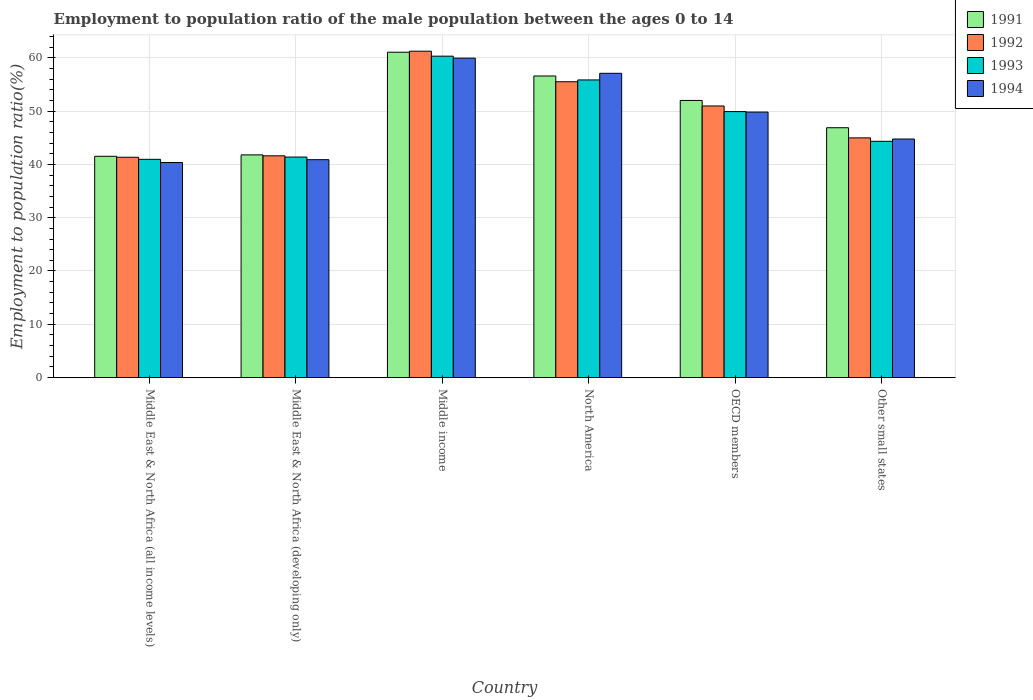How many different coloured bars are there?
Keep it short and to the point. 4. How many bars are there on the 2nd tick from the left?
Offer a very short reply. 4. How many bars are there on the 1st tick from the right?
Keep it short and to the point. 4. In how many cases, is the number of bars for a given country not equal to the number of legend labels?
Your response must be concise. 0. What is the employment to population ratio in 1993 in Middle East & North Africa (developing only)?
Offer a terse response. 41.37. Across all countries, what is the maximum employment to population ratio in 1994?
Keep it short and to the point. 59.91. Across all countries, what is the minimum employment to population ratio in 1992?
Offer a very short reply. 41.33. In which country was the employment to population ratio in 1993 minimum?
Provide a succinct answer. Middle East & North Africa (all income levels). What is the total employment to population ratio in 1992 in the graph?
Ensure brevity in your answer.  295.53. What is the difference between the employment to population ratio in 1992 in Middle East & North Africa (all income levels) and that in Other small states?
Make the answer very short. -3.64. What is the difference between the employment to population ratio in 1994 in Middle income and the employment to population ratio in 1992 in OECD members?
Your response must be concise. 8.96. What is the average employment to population ratio in 1991 per country?
Provide a short and direct response. 49.95. What is the difference between the employment to population ratio of/in 1994 and employment to population ratio of/in 1991 in OECD members?
Make the answer very short. -2.18. In how many countries, is the employment to population ratio in 1993 greater than 34 %?
Give a very brief answer. 6. What is the ratio of the employment to population ratio in 1992 in Middle East & North Africa (all income levels) to that in Middle income?
Your answer should be very brief. 0.68. Is the employment to population ratio in 1994 in Middle East & North Africa (all income levels) less than that in North America?
Your answer should be very brief. Yes. What is the difference between the highest and the second highest employment to population ratio in 1993?
Offer a terse response. -10.39. What is the difference between the highest and the lowest employment to population ratio in 1992?
Give a very brief answer. 19.89. What does the 2nd bar from the left in OECD members represents?
Give a very brief answer. 1992. Is it the case that in every country, the sum of the employment to population ratio in 1991 and employment to population ratio in 1994 is greater than the employment to population ratio in 1992?
Your answer should be very brief. Yes. How many bars are there?
Offer a terse response. 24. How many countries are there in the graph?
Keep it short and to the point. 6. What is the difference between two consecutive major ticks on the Y-axis?
Your response must be concise. 10. Does the graph contain any zero values?
Offer a very short reply. No. Does the graph contain grids?
Provide a succinct answer. Yes. What is the title of the graph?
Your answer should be very brief. Employment to population ratio of the male population between the ages 0 to 14. Does "1983" appear as one of the legend labels in the graph?
Keep it short and to the point. No. What is the label or title of the Y-axis?
Offer a very short reply. Employment to population ratio(%). What is the Employment to population ratio(%) of 1991 in Middle East & North Africa (all income levels)?
Your answer should be compact. 41.51. What is the Employment to population ratio(%) of 1992 in Middle East & North Africa (all income levels)?
Give a very brief answer. 41.33. What is the Employment to population ratio(%) in 1993 in Middle East & North Africa (all income levels)?
Ensure brevity in your answer.  40.94. What is the Employment to population ratio(%) in 1994 in Middle East & North Africa (all income levels)?
Provide a short and direct response. 40.34. What is the Employment to population ratio(%) of 1991 in Middle East & North Africa (developing only)?
Keep it short and to the point. 41.77. What is the Employment to population ratio(%) of 1992 in Middle East & North Africa (developing only)?
Make the answer very short. 41.6. What is the Employment to population ratio(%) in 1993 in Middle East & North Africa (developing only)?
Ensure brevity in your answer.  41.37. What is the Employment to population ratio(%) of 1994 in Middle East & North Africa (developing only)?
Offer a very short reply. 40.87. What is the Employment to population ratio(%) in 1991 in Middle income?
Offer a very short reply. 61.02. What is the Employment to population ratio(%) in 1992 in Middle income?
Your response must be concise. 61.21. What is the Employment to population ratio(%) of 1993 in Middle income?
Provide a succinct answer. 60.28. What is the Employment to population ratio(%) of 1994 in Middle income?
Offer a terse response. 59.91. What is the Employment to population ratio(%) of 1991 in North America?
Your response must be concise. 56.57. What is the Employment to population ratio(%) in 1992 in North America?
Keep it short and to the point. 55.48. What is the Employment to population ratio(%) of 1993 in North America?
Your answer should be compact. 55.83. What is the Employment to population ratio(%) in 1994 in North America?
Give a very brief answer. 57.07. What is the Employment to population ratio(%) of 1991 in OECD members?
Your answer should be compact. 51.98. What is the Employment to population ratio(%) in 1992 in OECD members?
Your answer should be very brief. 50.95. What is the Employment to population ratio(%) of 1993 in OECD members?
Offer a terse response. 49.89. What is the Employment to population ratio(%) of 1994 in OECD members?
Offer a terse response. 49.8. What is the Employment to population ratio(%) in 1991 in Other small states?
Offer a terse response. 46.86. What is the Employment to population ratio(%) in 1992 in Other small states?
Offer a very short reply. 44.96. What is the Employment to population ratio(%) of 1993 in Other small states?
Give a very brief answer. 44.32. What is the Employment to population ratio(%) of 1994 in Other small states?
Give a very brief answer. 44.75. Across all countries, what is the maximum Employment to population ratio(%) in 1991?
Your answer should be very brief. 61.02. Across all countries, what is the maximum Employment to population ratio(%) in 1992?
Your answer should be compact. 61.21. Across all countries, what is the maximum Employment to population ratio(%) in 1993?
Keep it short and to the point. 60.28. Across all countries, what is the maximum Employment to population ratio(%) of 1994?
Offer a very short reply. 59.91. Across all countries, what is the minimum Employment to population ratio(%) in 1991?
Offer a terse response. 41.51. Across all countries, what is the minimum Employment to population ratio(%) in 1992?
Your answer should be very brief. 41.33. Across all countries, what is the minimum Employment to population ratio(%) of 1993?
Your answer should be very brief. 40.94. Across all countries, what is the minimum Employment to population ratio(%) in 1994?
Keep it short and to the point. 40.34. What is the total Employment to population ratio(%) in 1991 in the graph?
Your response must be concise. 299.72. What is the total Employment to population ratio(%) of 1992 in the graph?
Your answer should be very brief. 295.53. What is the total Employment to population ratio(%) of 1993 in the graph?
Offer a terse response. 292.63. What is the total Employment to population ratio(%) in 1994 in the graph?
Ensure brevity in your answer.  292.74. What is the difference between the Employment to population ratio(%) of 1991 in Middle East & North Africa (all income levels) and that in Middle East & North Africa (developing only)?
Keep it short and to the point. -0.26. What is the difference between the Employment to population ratio(%) in 1992 in Middle East & North Africa (all income levels) and that in Middle East & North Africa (developing only)?
Ensure brevity in your answer.  -0.27. What is the difference between the Employment to population ratio(%) of 1993 in Middle East & North Africa (all income levels) and that in Middle East & North Africa (developing only)?
Provide a succinct answer. -0.43. What is the difference between the Employment to population ratio(%) of 1994 in Middle East & North Africa (all income levels) and that in Middle East & North Africa (developing only)?
Provide a succinct answer. -0.53. What is the difference between the Employment to population ratio(%) of 1991 in Middle East & North Africa (all income levels) and that in Middle income?
Offer a very short reply. -19.51. What is the difference between the Employment to population ratio(%) of 1992 in Middle East & North Africa (all income levels) and that in Middle income?
Ensure brevity in your answer.  -19.89. What is the difference between the Employment to population ratio(%) of 1993 in Middle East & North Africa (all income levels) and that in Middle income?
Ensure brevity in your answer.  -19.34. What is the difference between the Employment to population ratio(%) in 1994 in Middle East & North Africa (all income levels) and that in Middle income?
Your answer should be compact. -19.57. What is the difference between the Employment to population ratio(%) of 1991 in Middle East & North Africa (all income levels) and that in North America?
Provide a short and direct response. -15.06. What is the difference between the Employment to population ratio(%) of 1992 in Middle East & North Africa (all income levels) and that in North America?
Make the answer very short. -14.16. What is the difference between the Employment to population ratio(%) of 1993 in Middle East & North Africa (all income levels) and that in North America?
Offer a very short reply. -14.89. What is the difference between the Employment to population ratio(%) in 1994 in Middle East & North Africa (all income levels) and that in North America?
Give a very brief answer. -16.73. What is the difference between the Employment to population ratio(%) of 1991 in Middle East & North Africa (all income levels) and that in OECD members?
Your answer should be very brief. -10.47. What is the difference between the Employment to population ratio(%) of 1992 in Middle East & North Africa (all income levels) and that in OECD members?
Your response must be concise. -9.62. What is the difference between the Employment to population ratio(%) of 1993 in Middle East & North Africa (all income levels) and that in OECD members?
Give a very brief answer. -8.95. What is the difference between the Employment to population ratio(%) in 1994 in Middle East & North Africa (all income levels) and that in OECD members?
Keep it short and to the point. -9.46. What is the difference between the Employment to population ratio(%) of 1991 in Middle East & North Africa (all income levels) and that in Other small states?
Provide a short and direct response. -5.35. What is the difference between the Employment to population ratio(%) in 1992 in Middle East & North Africa (all income levels) and that in Other small states?
Give a very brief answer. -3.64. What is the difference between the Employment to population ratio(%) in 1993 in Middle East & North Africa (all income levels) and that in Other small states?
Make the answer very short. -3.38. What is the difference between the Employment to population ratio(%) of 1994 in Middle East & North Africa (all income levels) and that in Other small states?
Ensure brevity in your answer.  -4.41. What is the difference between the Employment to population ratio(%) of 1991 in Middle East & North Africa (developing only) and that in Middle income?
Provide a short and direct response. -19.25. What is the difference between the Employment to population ratio(%) in 1992 in Middle East & North Africa (developing only) and that in Middle income?
Ensure brevity in your answer.  -19.62. What is the difference between the Employment to population ratio(%) in 1993 in Middle East & North Africa (developing only) and that in Middle income?
Give a very brief answer. -18.92. What is the difference between the Employment to population ratio(%) in 1994 in Middle East & North Africa (developing only) and that in Middle income?
Your answer should be compact. -19.04. What is the difference between the Employment to population ratio(%) of 1991 in Middle East & North Africa (developing only) and that in North America?
Give a very brief answer. -14.8. What is the difference between the Employment to population ratio(%) in 1992 in Middle East & North Africa (developing only) and that in North America?
Your response must be concise. -13.89. What is the difference between the Employment to population ratio(%) in 1993 in Middle East & North Africa (developing only) and that in North America?
Your response must be concise. -14.46. What is the difference between the Employment to population ratio(%) of 1994 in Middle East & North Africa (developing only) and that in North America?
Offer a terse response. -16.19. What is the difference between the Employment to population ratio(%) in 1991 in Middle East & North Africa (developing only) and that in OECD members?
Offer a terse response. -10.21. What is the difference between the Employment to population ratio(%) of 1992 in Middle East & North Africa (developing only) and that in OECD members?
Give a very brief answer. -9.35. What is the difference between the Employment to population ratio(%) in 1993 in Middle East & North Africa (developing only) and that in OECD members?
Keep it short and to the point. -8.53. What is the difference between the Employment to population ratio(%) of 1994 in Middle East & North Africa (developing only) and that in OECD members?
Offer a very short reply. -8.92. What is the difference between the Employment to population ratio(%) in 1991 in Middle East & North Africa (developing only) and that in Other small states?
Your answer should be very brief. -5.09. What is the difference between the Employment to population ratio(%) in 1992 in Middle East & North Africa (developing only) and that in Other small states?
Your response must be concise. -3.37. What is the difference between the Employment to population ratio(%) in 1993 in Middle East & North Africa (developing only) and that in Other small states?
Keep it short and to the point. -2.95. What is the difference between the Employment to population ratio(%) of 1994 in Middle East & North Africa (developing only) and that in Other small states?
Provide a short and direct response. -3.87. What is the difference between the Employment to population ratio(%) of 1991 in Middle income and that in North America?
Your answer should be very brief. 4.45. What is the difference between the Employment to population ratio(%) in 1992 in Middle income and that in North America?
Ensure brevity in your answer.  5.73. What is the difference between the Employment to population ratio(%) of 1993 in Middle income and that in North America?
Keep it short and to the point. 4.46. What is the difference between the Employment to population ratio(%) in 1994 in Middle income and that in North America?
Keep it short and to the point. 2.84. What is the difference between the Employment to population ratio(%) of 1991 in Middle income and that in OECD members?
Your response must be concise. 9.04. What is the difference between the Employment to population ratio(%) in 1992 in Middle income and that in OECD members?
Offer a terse response. 10.27. What is the difference between the Employment to population ratio(%) in 1993 in Middle income and that in OECD members?
Offer a terse response. 10.39. What is the difference between the Employment to population ratio(%) of 1994 in Middle income and that in OECD members?
Offer a very short reply. 10.11. What is the difference between the Employment to population ratio(%) in 1991 in Middle income and that in Other small states?
Provide a succinct answer. 14.16. What is the difference between the Employment to population ratio(%) in 1992 in Middle income and that in Other small states?
Give a very brief answer. 16.25. What is the difference between the Employment to population ratio(%) in 1993 in Middle income and that in Other small states?
Your response must be concise. 15.96. What is the difference between the Employment to population ratio(%) of 1994 in Middle income and that in Other small states?
Keep it short and to the point. 15.16. What is the difference between the Employment to population ratio(%) of 1991 in North America and that in OECD members?
Your answer should be very brief. 4.59. What is the difference between the Employment to population ratio(%) of 1992 in North America and that in OECD members?
Ensure brevity in your answer.  4.54. What is the difference between the Employment to population ratio(%) in 1993 in North America and that in OECD members?
Make the answer very short. 5.93. What is the difference between the Employment to population ratio(%) in 1994 in North America and that in OECD members?
Provide a short and direct response. 7.27. What is the difference between the Employment to population ratio(%) of 1991 in North America and that in Other small states?
Make the answer very short. 9.7. What is the difference between the Employment to population ratio(%) in 1992 in North America and that in Other small states?
Provide a short and direct response. 10.52. What is the difference between the Employment to population ratio(%) of 1993 in North America and that in Other small states?
Make the answer very short. 11.51. What is the difference between the Employment to population ratio(%) of 1994 in North America and that in Other small states?
Keep it short and to the point. 12.32. What is the difference between the Employment to population ratio(%) of 1991 in OECD members and that in Other small states?
Provide a succinct answer. 5.12. What is the difference between the Employment to population ratio(%) of 1992 in OECD members and that in Other small states?
Your response must be concise. 5.98. What is the difference between the Employment to population ratio(%) of 1993 in OECD members and that in Other small states?
Offer a very short reply. 5.57. What is the difference between the Employment to population ratio(%) of 1994 in OECD members and that in Other small states?
Your answer should be very brief. 5.05. What is the difference between the Employment to population ratio(%) in 1991 in Middle East & North Africa (all income levels) and the Employment to population ratio(%) in 1992 in Middle East & North Africa (developing only)?
Your answer should be compact. -0.09. What is the difference between the Employment to population ratio(%) in 1991 in Middle East & North Africa (all income levels) and the Employment to population ratio(%) in 1993 in Middle East & North Africa (developing only)?
Your answer should be very brief. 0.14. What is the difference between the Employment to population ratio(%) of 1991 in Middle East & North Africa (all income levels) and the Employment to population ratio(%) of 1994 in Middle East & North Africa (developing only)?
Your answer should be very brief. 0.64. What is the difference between the Employment to population ratio(%) of 1992 in Middle East & North Africa (all income levels) and the Employment to population ratio(%) of 1993 in Middle East & North Africa (developing only)?
Provide a succinct answer. -0.04. What is the difference between the Employment to population ratio(%) in 1992 in Middle East & North Africa (all income levels) and the Employment to population ratio(%) in 1994 in Middle East & North Africa (developing only)?
Make the answer very short. 0.45. What is the difference between the Employment to population ratio(%) in 1993 in Middle East & North Africa (all income levels) and the Employment to population ratio(%) in 1994 in Middle East & North Africa (developing only)?
Offer a very short reply. 0.06. What is the difference between the Employment to population ratio(%) in 1991 in Middle East & North Africa (all income levels) and the Employment to population ratio(%) in 1992 in Middle income?
Your answer should be very brief. -19.7. What is the difference between the Employment to population ratio(%) in 1991 in Middle East & North Africa (all income levels) and the Employment to population ratio(%) in 1993 in Middle income?
Give a very brief answer. -18.77. What is the difference between the Employment to population ratio(%) in 1991 in Middle East & North Africa (all income levels) and the Employment to population ratio(%) in 1994 in Middle income?
Offer a very short reply. -18.4. What is the difference between the Employment to population ratio(%) in 1992 in Middle East & North Africa (all income levels) and the Employment to population ratio(%) in 1993 in Middle income?
Keep it short and to the point. -18.96. What is the difference between the Employment to population ratio(%) of 1992 in Middle East & North Africa (all income levels) and the Employment to population ratio(%) of 1994 in Middle income?
Ensure brevity in your answer.  -18.58. What is the difference between the Employment to population ratio(%) of 1993 in Middle East & North Africa (all income levels) and the Employment to population ratio(%) of 1994 in Middle income?
Your response must be concise. -18.97. What is the difference between the Employment to population ratio(%) of 1991 in Middle East & North Africa (all income levels) and the Employment to population ratio(%) of 1992 in North America?
Give a very brief answer. -13.97. What is the difference between the Employment to population ratio(%) in 1991 in Middle East & North Africa (all income levels) and the Employment to population ratio(%) in 1993 in North America?
Provide a succinct answer. -14.32. What is the difference between the Employment to population ratio(%) of 1991 in Middle East & North Africa (all income levels) and the Employment to population ratio(%) of 1994 in North America?
Provide a short and direct response. -15.56. What is the difference between the Employment to population ratio(%) in 1992 in Middle East & North Africa (all income levels) and the Employment to population ratio(%) in 1993 in North America?
Your answer should be very brief. -14.5. What is the difference between the Employment to population ratio(%) of 1992 in Middle East & North Africa (all income levels) and the Employment to population ratio(%) of 1994 in North America?
Your answer should be very brief. -15.74. What is the difference between the Employment to population ratio(%) of 1993 in Middle East & North Africa (all income levels) and the Employment to population ratio(%) of 1994 in North America?
Provide a short and direct response. -16.13. What is the difference between the Employment to population ratio(%) in 1991 in Middle East & North Africa (all income levels) and the Employment to population ratio(%) in 1992 in OECD members?
Your response must be concise. -9.44. What is the difference between the Employment to population ratio(%) of 1991 in Middle East & North Africa (all income levels) and the Employment to population ratio(%) of 1993 in OECD members?
Provide a short and direct response. -8.38. What is the difference between the Employment to population ratio(%) of 1991 in Middle East & North Africa (all income levels) and the Employment to population ratio(%) of 1994 in OECD members?
Keep it short and to the point. -8.29. What is the difference between the Employment to population ratio(%) in 1992 in Middle East & North Africa (all income levels) and the Employment to population ratio(%) in 1993 in OECD members?
Provide a short and direct response. -8.56. What is the difference between the Employment to population ratio(%) of 1992 in Middle East & North Africa (all income levels) and the Employment to population ratio(%) of 1994 in OECD members?
Provide a succinct answer. -8.47. What is the difference between the Employment to population ratio(%) of 1993 in Middle East & North Africa (all income levels) and the Employment to population ratio(%) of 1994 in OECD members?
Make the answer very short. -8.86. What is the difference between the Employment to population ratio(%) of 1991 in Middle East & North Africa (all income levels) and the Employment to population ratio(%) of 1992 in Other small states?
Offer a very short reply. -3.45. What is the difference between the Employment to population ratio(%) in 1991 in Middle East & North Africa (all income levels) and the Employment to population ratio(%) in 1993 in Other small states?
Make the answer very short. -2.81. What is the difference between the Employment to population ratio(%) in 1991 in Middle East & North Africa (all income levels) and the Employment to population ratio(%) in 1994 in Other small states?
Keep it short and to the point. -3.24. What is the difference between the Employment to population ratio(%) in 1992 in Middle East & North Africa (all income levels) and the Employment to population ratio(%) in 1993 in Other small states?
Give a very brief answer. -2.99. What is the difference between the Employment to population ratio(%) of 1992 in Middle East & North Africa (all income levels) and the Employment to population ratio(%) of 1994 in Other small states?
Keep it short and to the point. -3.42. What is the difference between the Employment to population ratio(%) of 1993 in Middle East & North Africa (all income levels) and the Employment to population ratio(%) of 1994 in Other small states?
Provide a short and direct response. -3.81. What is the difference between the Employment to population ratio(%) in 1991 in Middle East & North Africa (developing only) and the Employment to population ratio(%) in 1992 in Middle income?
Your answer should be very brief. -19.44. What is the difference between the Employment to population ratio(%) in 1991 in Middle East & North Africa (developing only) and the Employment to population ratio(%) in 1993 in Middle income?
Provide a succinct answer. -18.51. What is the difference between the Employment to population ratio(%) in 1991 in Middle East & North Africa (developing only) and the Employment to population ratio(%) in 1994 in Middle income?
Offer a very short reply. -18.14. What is the difference between the Employment to population ratio(%) of 1992 in Middle East & North Africa (developing only) and the Employment to population ratio(%) of 1993 in Middle income?
Make the answer very short. -18.69. What is the difference between the Employment to population ratio(%) in 1992 in Middle East & North Africa (developing only) and the Employment to population ratio(%) in 1994 in Middle income?
Provide a short and direct response. -18.31. What is the difference between the Employment to population ratio(%) of 1993 in Middle East & North Africa (developing only) and the Employment to population ratio(%) of 1994 in Middle income?
Your answer should be very brief. -18.54. What is the difference between the Employment to population ratio(%) in 1991 in Middle East & North Africa (developing only) and the Employment to population ratio(%) in 1992 in North America?
Offer a very short reply. -13.71. What is the difference between the Employment to population ratio(%) of 1991 in Middle East & North Africa (developing only) and the Employment to population ratio(%) of 1993 in North America?
Your answer should be compact. -14.05. What is the difference between the Employment to population ratio(%) of 1991 in Middle East & North Africa (developing only) and the Employment to population ratio(%) of 1994 in North America?
Offer a very short reply. -15.3. What is the difference between the Employment to population ratio(%) in 1992 in Middle East & North Africa (developing only) and the Employment to population ratio(%) in 1993 in North America?
Give a very brief answer. -14.23. What is the difference between the Employment to population ratio(%) of 1992 in Middle East & North Africa (developing only) and the Employment to population ratio(%) of 1994 in North America?
Make the answer very short. -15.47. What is the difference between the Employment to population ratio(%) of 1993 in Middle East & North Africa (developing only) and the Employment to population ratio(%) of 1994 in North America?
Offer a very short reply. -15.7. What is the difference between the Employment to population ratio(%) of 1991 in Middle East & North Africa (developing only) and the Employment to population ratio(%) of 1992 in OECD members?
Your answer should be compact. -9.17. What is the difference between the Employment to population ratio(%) of 1991 in Middle East & North Africa (developing only) and the Employment to population ratio(%) of 1993 in OECD members?
Your response must be concise. -8.12. What is the difference between the Employment to population ratio(%) in 1991 in Middle East & North Africa (developing only) and the Employment to population ratio(%) in 1994 in OECD members?
Your answer should be very brief. -8.03. What is the difference between the Employment to population ratio(%) of 1992 in Middle East & North Africa (developing only) and the Employment to population ratio(%) of 1993 in OECD members?
Provide a short and direct response. -8.3. What is the difference between the Employment to population ratio(%) of 1992 in Middle East & North Africa (developing only) and the Employment to population ratio(%) of 1994 in OECD members?
Provide a succinct answer. -8.2. What is the difference between the Employment to population ratio(%) in 1993 in Middle East & North Africa (developing only) and the Employment to population ratio(%) in 1994 in OECD members?
Give a very brief answer. -8.43. What is the difference between the Employment to population ratio(%) in 1991 in Middle East & North Africa (developing only) and the Employment to population ratio(%) in 1992 in Other small states?
Offer a very short reply. -3.19. What is the difference between the Employment to population ratio(%) of 1991 in Middle East & North Africa (developing only) and the Employment to population ratio(%) of 1993 in Other small states?
Provide a succinct answer. -2.55. What is the difference between the Employment to population ratio(%) in 1991 in Middle East & North Africa (developing only) and the Employment to population ratio(%) in 1994 in Other small states?
Ensure brevity in your answer.  -2.98. What is the difference between the Employment to population ratio(%) of 1992 in Middle East & North Africa (developing only) and the Employment to population ratio(%) of 1993 in Other small states?
Keep it short and to the point. -2.72. What is the difference between the Employment to population ratio(%) in 1992 in Middle East & North Africa (developing only) and the Employment to population ratio(%) in 1994 in Other small states?
Give a very brief answer. -3.15. What is the difference between the Employment to population ratio(%) in 1993 in Middle East & North Africa (developing only) and the Employment to population ratio(%) in 1994 in Other small states?
Your response must be concise. -3.38. What is the difference between the Employment to population ratio(%) in 1991 in Middle income and the Employment to population ratio(%) in 1992 in North America?
Keep it short and to the point. 5.54. What is the difference between the Employment to population ratio(%) in 1991 in Middle income and the Employment to population ratio(%) in 1993 in North America?
Keep it short and to the point. 5.19. What is the difference between the Employment to population ratio(%) of 1991 in Middle income and the Employment to population ratio(%) of 1994 in North America?
Keep it short and to the point. 3.95. What is the difference between the Employment to population ratio(%) in 1992 in Middle income and the Employment to population ratio(%) in 1993 in North America?
Offer a very short reply. 5.39. What is the difference between the Employment to population ratio(%) in 1992 in Middle income and the Employment to population ratio(%) in 1994 in North America?
Offer a terse response. 4.15. What is the difference between the Employment to population ratio(%) of 1993 in Middle income and the Employment to population ratio(%) of 1994 in North America?
Make the answer very short. 3.21. What is the difference between the Employment to population ratio(%) of 1991 in Middle income and the Employment to population ratio(%) of 1992 in OECD members?
Your answer should be compact. 10.07. What is the difference between the Employment to population ratio(%) in 1991 in Middle income and the Employment to population ratio(%) in 1993 in OECD members?
Your answer should be compact. 11.13. What is the difference between the Employment to population ratio(%) of 1991 in Middle income and the Employment to population ratio(%) of 1994 in OECD members?
Keep it short and to the point. 11.22. What is the difference between the Employment to population ratio(%) of 1992 in Middle income and the Employment to population ratio(%) of 1993 in OECD members?
Your answer should be compact. 11.32. What is the difference between the Employment to population ratio(%) of 1992 in Middle income and the Employment to population ratio(%) of 1994 in OECD members?
Keep it short and to the point. 11.41. What is the difference between the Employment to population ratio(%) of 1993 in Middle income and the Employment to population ratio(%) of 1994 in OECD members?
Provide a short and direct response. 10.48. What is the difference between the Employment to population ratio(%) in 1991 in Middle income and the Employment to population ratio(%) in 1992 in Other small states?
Provide a succinct answer. 16.06. What is the difference between the Employment to population ratio(%) in 1991 in Middle income and the Employment to population ratio(%) in 1993 in Other small states?
Ensure brevity in your answer.  16.7. What is the difference between the Employment to population ratio(%) of 1991 in Middle income and the Employment to population ratio(%) of 1994 in Other small states?
Make the answer very short. 16.27. What is the difference between the Employment to population ratio(%) in 1992 in Middle income and the Employment to population ratio(%) in 1993 in Other small states?
Ensure brevity in your answer.  16.89. What is the difference between the Employment to population ratio(%) in 1992 in Middle income and the Employment to population ratio(%) in 1994 in Other small states?
Your answer should be compact. 16.46. What is the difference between the Employment to population ratio(%) in 1993 in Middle income and the Employment to population ratio(%) in 1994 in Other small states?
Give a very brief answer. 15.53. What is the difference between the Employment to population ratio(%) of 1991 in North America and the Employment to population ratio(%) of 1992 in OECD members?
Your response must be concise. 5.62. What is the difference between the Employment to population ratio(%) of 1991 in North America and the Employment to population ratio(%) of 1993 in OECD members?
Your response must be concise. 6.68. What is the difference between the Employment to population ratio(%) of 1991 in North America and the Employment to population ratio(%) of 1994 in OECD members?
Make the answer very short. 6.77. What is the difference between the Employment to population ratio(%) in 1992 in North America and the Employment to population ratio(%) in 1993 in OECD members?
Offer a terse response. 5.59. What is the difference between the Employment to population ratio(%) in 1992 in North America and the Employment to population ratio(%) in 1994 in OECD members?
Ensure brevity in your answer.  5.68. What is the difference between the Employment to population ratio(%) in 1993 in North America and the Employment to population ratio(%) in 1994 in OECD members?
Your answer should be very brief. 6.03. What is the difference between the Employment to population ratio(%) in 1991 in North America and the Employment to population ratio(%) in 1992 in Other small states?
Your answer should be compact. 11.61. What is the difference between the Employment to population ratio(%) of 1991 in North America and the Employment to population ratio(%) of 1993 in Other small states?
Your answer should be compact. 12.25. What is the difference between the Employment to population ratio(%) in 1991 in North America and the Employment to population ratio(%) in 1994 in Other small states?
Provide a succinct answer. 11.82. What is the difference between the Employment to population ratio(%) in 1992 in North America and the Employment to population ratio(%) in 1993 in Other small states?
Provide a succinct answer. 11.16. What is the difference between the Employment to population ratio(%) of 1992 in North America and the Employment to population ratio(%) of 1994 in Other small states?
Your answer should be very brief. 10.73. What is the difference between the Employment to population ratio(%) in 1993 in North America and the Employment to population ratio(%) in 1994 in Other small states?
Your response must be concise. 11.08. What is the difference between the Employment to population ratio(%) in 1991 in OECD members and the Employment to population ratio(%) in 1992 in Other small states?
Provide a short and direct response. 7.02. What is the difference between the Employment to population ratio(%) of 1991 in OECD members and the Employment to population ratio(%) of 1993 in Other small states?
Keep it short and to the point. 7.66. What is the difference between the Employment to population ratio(%) of 1991 in OECD members and the Employment to population ratio(%) of 1994 in Other small states?
Offer a terse response. 7.23. What is the difference between the Employment to population ratio(%) in 1992 in OECD members and the Employment to population ratio(%) in 1993 in Other small states?
Your answer should be compact. 6.63. What is the difference between the Employment to population ratio(%) in 1992 in OECD members and the Employment to population ratio(%) in 1994 in Other small states?
Offer a very short reply. 6.2. What is the difference between the Employment to population ratio(%) in 1993 in OECD members and the Employment to population ratio(%) in 1994 in Other small states?
Provide a short and direct response. 5.14. What is the average Employment to population ratio(%) of 1991 per country?
Give a very brief answer. 49.95. What is the average Employment to population ratio(%) of 1992 per country?
Offer a terse response. 49.25. What is the average Employment to population ratio(%) in 1993 per country?
Your response must be concise. 48.77. What is the average Employment to population ratio(%) of 1994 per country?
Your response must be concise. 48.79. What is the difference between the Employment to population ratio(%) of 1991 and Employment to population ratio(%) of 1992 in Middle East & North Africa (all income levels)?
Ensure brevity in your answer.  0.18. What is the difference between the Employment to population ratio(%) of 1991 and Employment to population ratio(%) of 1993 in Middle East & North Africa (all income levels)?
Your response must be concise. 0.57. What is the difference between the Employment to population ratio(%) of 1991 and Employment to population ratio(%) of 1994 in Middle East & North Africa (all income levels)?
Offer a very short reply. 1.17. What is the difference between the Employment to population ratio(%) of 1992 and Employment to population ratio(%) of 1993 in Middle East & North Africa (all income levels)?
Ensure brevity in your answer.  0.39. What is the difference between the Employment to population ratio(%) of 1992 and Employment to population ratio(%) of 1994 in Middle East & North Africa (all income levels)?
Keep it short and to the point. 0.99. What is the difference between the Employment to population ratio(%) in 1993 and Employment to population ratio(%) in 1994 in Middle East & North Africa (all income levels)?
Your answer should be compact. 0.6. What is the difference between the Employment to population ratio(%) in 1991 and Employment to population ratio(%) in 1992 in Middle East & North Africa (developing only)?
Ensure brevity in your answer.  0.18. What is the difference between the Employment to population ratio(%) of 1991 and Employment to population ratio(%) of 1993 in Middle East & North Africa (developing only)?
Give a very brief answer. 0.41. What is the difference between the Employment to population ratio(%) of 1991 and Employment to population ratio(%) of 1994 in Middle East & North Africa (developing only)?
Make the answer very short. 0.9. What is the difference between the Employment to population ratio(%) of 1992 and Employment to population ratio(%) of 1993 in Middle East & North Africa (developing only)?
Keep it short and to the point. 0.23. What is the difference between the Employment to population ratio(%) of 1992 and Employment to population ratio(%) of 1994 in Middle East & North Africa (developing only)?
Provide a short and direct response. 0.72. What is the difference between the Employment to population ratio(%) in 1993 and Employment to population ratio(%) in 1994 in Middle East & North Africa (developing only)?
Your answer should be very brief. 0.49. What is the difference between the Employment to population ratio(%) of 1991 and Employment to population ratio(%) of 1992 in Middle income?
Your answer should be very brief. -0.19. What is the difference between the Employment to population ratio(%) of 1991 and Employment to population ratio(%) of 1993 in Middle income?
Offer a very short reply. 0.74. What is the difference between the Employment to population ratio(%) of 1991 and Employment to population ratio(%) of 1994 in Middle income?
Keep it short and to the point. 1.11. What is the difference between the Employment to population ratio(%) in 1992 and Employment to population ratio(%) in 1993 in Middle income?
Your response must be concise. 0.93. What is the difference between the Employment to population ratio(%) in 1992 and Employment to population ratio(%) in 1994 in Middle income?
Your answer should be compact. 1.3. What is the difference between the Employment to population ratio(%) of 1993 and Employment to population ratio(%) of 1994 in Middle income?
Offer a very short reply. 0.37. What is the difference between the Employment to population ratio(%) in 1991 and Employment to population ratio(%) in 1992 in North America?
Make the answer very short. 1.09. What is the difference between the Employment to population ratio(%) in 1991 and Employment to population ratio(%) in 1993 in North America?
Give a very brief answer. 0.74. What is the difference between the Employment to population ratio(%) of 1991 and Employment to population ratio(%) of 1994 in North America?
Make the answer very short. -0.5. What is the difference between the Employment to population ratio(%) of 1992 and Employment to population ratio(%) of 1993 in North America?
Ensure brevity in your answer.  -0.34. What is the difference between the Employment to population ratio(%) in 1992 and Employment to population ratio(%) in 1994 in North America?
Keep it short and to the point. -1.59. What is the difference between the Employment to population ratio(%) in 1993 and Employment to population ratio(%) in 1994 in North America?
Offer a very short reply. -1.24. What is the difference between the Employment to population ratio(%) in 1991 and Employment to population ratio(%) in 1992 in OECD members?
Offer a terse response. 1.03. What is the difference between the Employment to population ratio(%) of 1991 and Employment to population ratio(%) of 1993 in OECD members?
Offer a very short reply. 2.09. What is the difference between the Employment to population ratio(%) of 1991 and Employment to population ratio(%) of 1994 in OECD members?
Ensure brevity in your answer.  2.18. What is the difference between the Employment to population ratio(%) of 1992 and Employment to population ratio(%) of 1993 in OECD members?
Your answer should be compact. 1.05. What is the difference between the Employment to population ratio(%) of 1992 and Employment to population ratio(%) of 1994 in OECD members?
Your answer should be compact. 1.15. What is the difference between the Employment to population ratio(%) in 1993 and Employment to population ratio(%) in 1994 in OECD members?
Your response must be concise. 0.09. What is the difference between the Employment to population ratio(%) of 1991 and Employment to population ratio(%) of 1992 in Other small states?
Offer a very short reply. 1.9. What is the difference between the Employment to population ratio(%) of 1991 and Employment to population ratio(%) of 1993 in Other small states?
Provide a short and direct response. 2.54. What is the difference between the Employment to population ratio(%) of 1991 and Employment to population ratio(%) of 1994 in Other small states?
Your answer should be compact. 2.11. What is the difference between the Employment to population ratio(%) of 1992 and Employment to population ratio(%) of 1993 in Other small states?
Give a very brief answer. 0.64. What is the difference between the Employment to population ratio(%) of 1992 and Employment to population ratio(%) of 1994 in Other small states?
Keep it short and to the point. 0.21. What is the difference between the Employment to population ratio(%) in 1993 and Employment to population ratio(%) in 1994 in Other small states?
Your response must be concise. -0.43. What is the ratio of the Employment to population ratio(%) in 1994 in Middle East & North Africa (all income levels) to that in Middle East & North Africa (developing only)?
Keep it short and to the point. 0.99. What is the ratio of the Employment to population ratio(%) of 1991 in Middle East & North Africa (all income levels) to that in Middle income?
Your answer should be very brief. 0.68. What is the ratio of the Employment to population ratio(%) of 1992 in Middle East & North Africa (all income levels) to that in Middle income?
Offer a very short reply. 0.68. What is the ratio of the Employment to population ratio(%) of 1993 in Middle East & North Africa (all income levels) to that in Middle income?
Keep it short and to the point. 0.68. What is the ratio of the Employment to population ratio(%) of 1994 in Middle East & North Africa (all income levels) to that in Middle income?
Provide a short and direct response. 0.67. What is the ratio of the Employment to population ratio(%) of 1991 in Middle East & North Africa (all income levels) to that in North America?
Offer a terse response. 0.73. What is the ratio of the Employment to population ratio(%) in 1992 in Middle East & North Africa (all income levels) to that in North America?
Your answer should be compact. 0.74. What is the ratio of the Employment to population ratio(%) of 1993 in Middle East & North Africa (all income levels) to that in North America?
Provide a short and direct response. 0.73. What is the ratio of the Employment to population ratio(%) in 1994 in Middle East & North Africa (all income levels) to that in North America?
Keep it short and to the point. 0.71. What is the ratio of the Employment to population ratio(%) in 1991 in Middle East & North Africa (all income levels) to that in OECD members?
Give a very brief answer. 0.8. What is the ratio of the Employment to population ratio(%) in 1992 in Middle East & North Africa (all income levels) to that in OECD members?
Offer a very short reply. 0.81. What is the ratio of the Employment to population ratio(%) in 1993 in Middle East & North Africa (all income levels) to that in OECD members?
Provide a short and direct response. 0.82. What is the ratio of the Employment to population ratio(%) of 1994 in Middle East & North Africa (all income levels) to that in OECD members?
Your answer should be compact. 0.81. What is the ratio of the Employment to population ratio(%) in 1991 in Middle East & North Africa (all income levels) to that in Other small states?
Offer a terse response. 0.89. What is the ratio of the Employment to population ratio(%) of 1992 in Middle East & North Africa (all income levels) to that in Other small states?
Your answer should be compact. 0.92. What is the ratio of the Employment to population ratio(%) in 1993 in Middle East & North Africa (all income levels) to that in Other small states?
Provide a short and direct response. 0.92. What is the ratio of the Employment to population ratio(%) of 1994 in Middle East & North Africa (all income levels) to that in Other small states?
Give a very brief answer. 0.9. What is the ratio of the Employment to population ratio(%) of 1991 in Middle East & North Africa (developing only) to that in Middle income?
Offer a very short reply. 0.68. What is the ratio of the Employment to population ratio(%) of 1992 in Middle East & North Africa (developing only) to that in Middle income?
Your answer should be very brief. 0.68. What is the ratio of the Employment to population ratio(%) of 1993 in Middle East & North Africa (developing only) to that in Middle income?
Offer a terse response. 0.69. What is the ratio of the Employment to population ratio(%) of 1994 in Middle East & North Africa (developing only) to that in Middle income?
Keep it short and to the point. 0.68. What is the ratio of the Employment to population ratio(%) in 1991 in Middle East & North Africa (developing only) to that in North America?
Offer a very short reply. 0.74. What is the ratio of the Employment to population ratio(%) of 1992 in Middle East & North Africa (developing only) to that in North America?
Provide a short and direct response. 0.75. What is the ratio of the Employment to population ratio(%) in 1993 in Middle East & North Africa (developing only) to that in North America?
Provide a succinct answer. 0.74. What is the ratio of the Employment to population ratio(%) of 1994 in Middle East & North Africa (developing only) to that in North America?
Offer a very short reply. 0.72. What is the ratio of the Employment to population ratio(%) in 1991 in Middle East & North Africa (developing only) to that in OECD members?
Give a very brief answer. 0.8. What is the ratio of the Employment to population ratio(%) in 1992 in Middle East & North Africa (developing only) to that in OECD members?
Offer a very short reply. 0.82. What is the ratio of the Employment to population ratio(%) in 1993 in Middle East & North Africa (developing only) to that in OECD members?
Your answer should be very brief. 0.83. What is the ratio of the Employment to population ratio(%) in 1994 in Middle East & North Africa (developing only) to that in OECD members?
Keep it short and to the point. 0.82. What is the ratio of the Employment to population ratio(%) in 1991 in Middle East & North Africa (developing only) to that in Other small states?
Keep it short and to the point. 0.89. What is the ratio of the Employment to population ratio(%) in 1992 in Middle East & North Africa (developing only) to that in Other small states?
Ensure brevity in your answer.  0.93. What is the ratio of the Employment to population ratio(%) in 1993 in Middle East & North Africa (developing only) to that in Other small states?
Provide a succinct answer. 0.93. What is the ratio of the Employment to population ratio(%) in 1994 in Middle East & North Africa (developing only) to that in Other small states?
Keep it short and to the point. 0.91. What is the ratio of the Employment to population ratio(%) in 1991 in Middle income to that in North America?
Offer a terse response. 1.08. What is the ratio of the Employment to population ratio(%) in 1992 in Middle income to that in North America?
Offer a very short reply. 1.1. What is the ratio of the Employment to population ratio(%) in 1993 in Middle income to that in North America?
Make the answer very short. 1.08. What is the ratio of the Employment to population ratio(%) in 1994 in Middle income to that in North America?
Make the answer very short. 1.05. What is the ratio of the Employment to population ratio(%) in 1991 in Middle income to that in OECD members?
Your answer should be very brief. 1.17. What is the ratio of the Employment to population ratio(%) in 1992 in Middle income to that in OECD members?
Offer a very short reply. 1.2. What is the ratio of the Employment to population ratio(%) of 1993 in Middle income to that in OECD members?
Offer a very short reply. 1.21. What is the ratio of the Employment to population ratio(%) of 1994 in Middle income to that in OECD members?
Your answer should be compact. 1.2. What is the ratio of the Employment to population ratio(%) in 1991 in Middle income to that in Other small states?
Keep it short and to the point. 1.3. What is the ratio of the Employment to population ratio(%) of 1992 in Middle income to that in Other small states?
Your answer should be very brief. 1.36. What is the ratio of the Employment to population ratio(%) of 1993 in Middle income to that in Other small states?
Offer a very short reply. 1.36. What is the ratio of the Employment to population ratio(%) of 1994 in Middle income to that in Other small states?
Provide a short and direct response. 1.34. What is the ratio of the Employment to population ratio(%) in 1991 in North America to that in OECD members?
Offer a terse response. 1.09. What is the ratio of the Employment to population ratio(%) in 1992 in North America to that in OECD members?
Provide a short and direct response. 1.09. What is the ratio of the Employment to population ratio(%) in 1993 in North America to that in OECD members?
Your response must be concise. 1.12. What is the ratio of the Employment to population ratio(%) in 1994 in North America to that in OECD members?
Offer a terse response. 1.15. What is the ratio of the Employment to population ratio(%) in 1991 in North America to that in Other small states?
Provide a short and direct response. 1.21. What is the ratio of the Employment to population ratio(%) in 1992 in North America to that in Other small states?
Make the answer very short. 1.23. What is the ratio of the Employment to population ratio(%) of 1993 in North America to that in Other small states?
Offer a very short reply. 1.26. What is the ratio of the Employment to population ratio(%) in 1994 in North America to that in Other small states?
Give a very brief answer. 1.28. What is the ratio of the Employment to population ratio(%) in 1991 in OECD members to that in Other small states?
Offer a very short reply. 1.11. What is the ratio of the Employment to population ratio(%) in 1992 in OECD members to that in Other small states?
Provide a short and direct response. 1.13. What is the ratio of the Employment to population ratio(%) of 1993 in OECD members to that in Other small states?
Offer a terse response. 1.13. What is the ratio of the Employment to population ratio(%) in 1994 in OECD members to that in Other small states?
Make the answer very short. 1.11. What is the difference between the highest and the second highest Employment to population ratio(%) in 1991?
Your answer should be very brief. 4.45. What is the difference between the highest and the second highest Employment to population ratio(%) of 1992?
Provide a succinct answer. 5.73. What is the difference between the highest and the second highest Employment to population ratio(%) of 1993?
Ensure brevity in your answer.  4.46. What is the difference between the highest and the second highest Employment to population ratio(%) of 1994?
Provide a short and direct response. 2.84. What is the difference between the highest and the lowest Employment to population ratio(%) of 1991?
Provide a short and direct response. 19.51. What is the difference between the highest and the lowest Employment to population ratio(%) in 1992?
Give a very brief answer. 19.89. What is the difference between the highest and the lowest Employment to population ratio(%) in 1993?
Offer a terse response. 19.34. What is the difference between the highest and the lowest Employment to population ratio(%) of 1994?
Give a very brief answer. 19.57. 